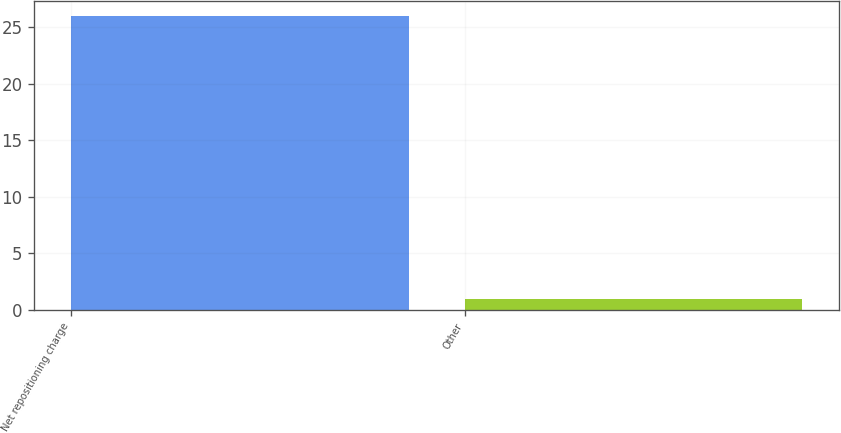<chart> <loc_0><loc_0><loc_500><loc_500><bar_chart><fcel>Net repositioning charge<fcel>Other<nl><fcel>26<fcel>1<nl></chart> 